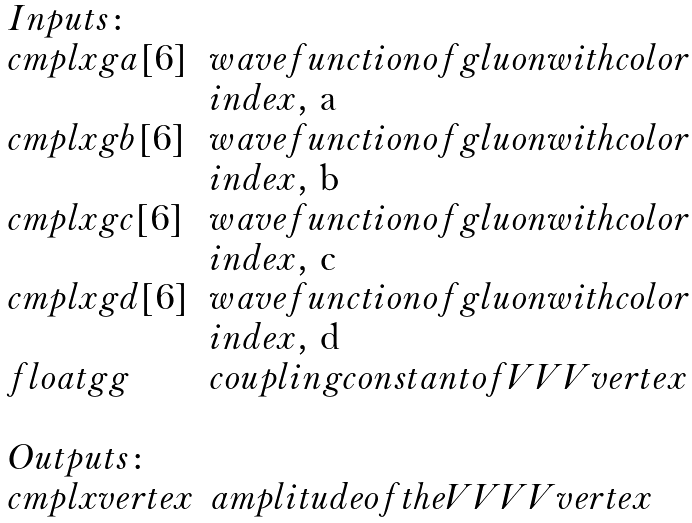Convert formula to latex. <formula><loc_0><loc_0><loc_500><loc_500>\begin{array} { l l } I n p u t s \colon & \\ c m p l x g a [ 6 ] & w a v e f u n c t i o n o f g l u o n w i t h c o l o r \\ & i n d e x , $ a $ \\ c m p l x g b [ 6 ] & w a v e f u n c t i o n o f g l u o n w i t h c o l o r \\ & i n d e x , $ b $ \\ c m p l x g c [ 6 ] & w a v e f u n c t i o n o f g l u o n w i t h c o l o r \\ & i n d e x , $ c $ \\ c m p l x g d [ 6 ] & w a v e f u n c t i o n o f g l u o n w i t h c o l o r \\ & i n d e x , $ d $ \\ f l o a t g g & c o u p l i n g c o n s t a n t o f V V V v e r t e x \\ \\ O u t p u t s \colon & \\ c m p l x v e r t e x & a m p l i t u d e o f t h e V V V V v e r t e x \end{array}</formula> 